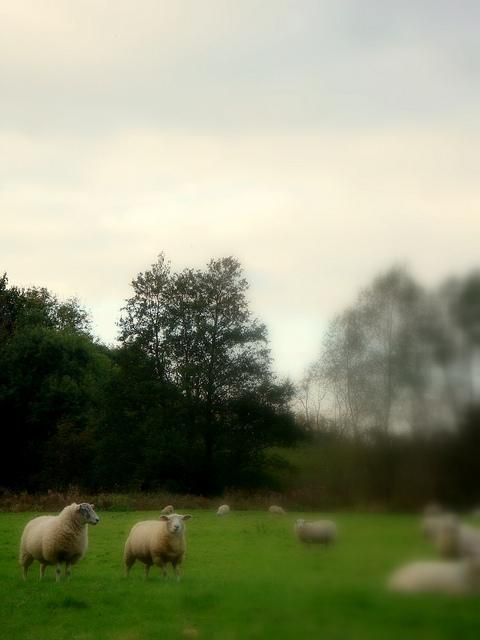What is the condition of the sky? Please explain your reasoning. overcast. The condition is gray. 